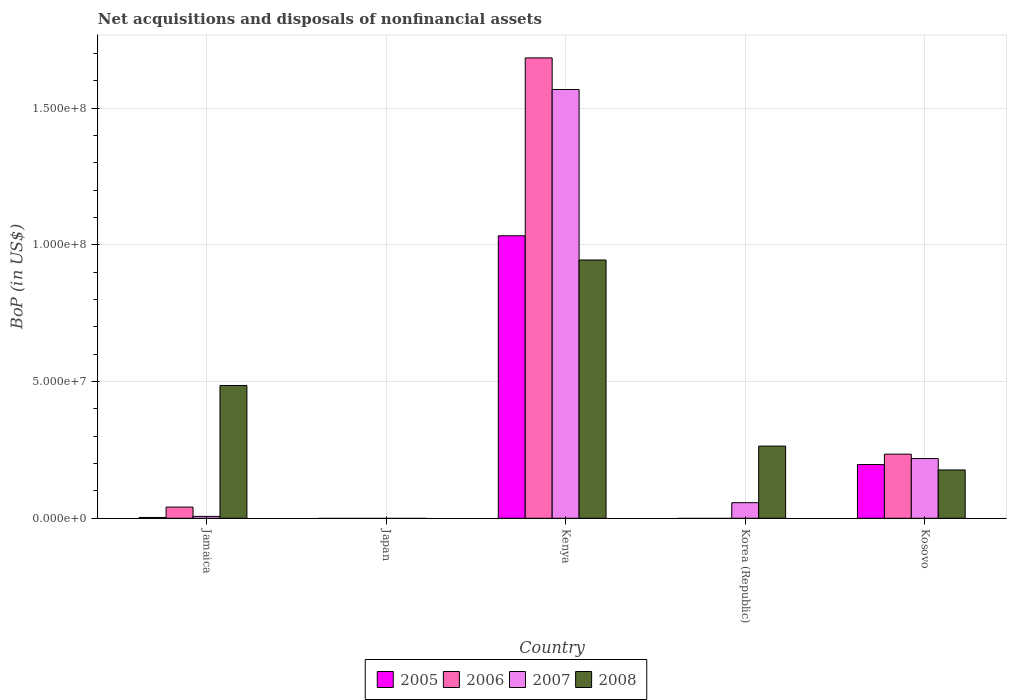How many different coloured bars are there?
Offer a very short reply. 4. Are the number of bars per tick equal to the number of legend labels?
Make the answer very short. No. Are the number of bars on each tick of the X-axis equal?
Keep it short and to the point. No. What is the label of the 4th group of bars from the left?
Give a very brief answer. Korea (Republic). In how many cases, is the number of bars for a given country not equal to the number of legend labels?
Give a very brief answer. 2. What is the Balance of Payments in 2008 in Jamaica?
Ensure brevity in your answer.  4.86e+07. Across all countries, what is the maximum Balance of Payments in 2008?
Ensure brevity in your answer.  9.45e+07. Across all countries, what is the minimum Balance of Payments in 2007?
Keep it short and to the point. 0. In which country was the Balance of Payments in 2006 maximum?
Offer a very short reply. Kenya. What is the total Balance of Payments in 2007 in the graph?
Give a very brief answer. 1.85e+08. What is the difference between the Balance of Payments in 2005 in Jamaica and that in Kosovo?
Offer a terse response. -1.93e+07. What is the difference between the Balance of Payments in 2007 in Korea (Republic) and the Balance of Payments in 2005 in Kenya?
Keep it short and to the point. -9.76e+07. What is the average Balance of Payments in 2008 per country?
Make the answer very short. 3.74e+07. What is the difference between the Balance of Payments of/in 2008 and Balance of Payments of/in 2006 in Kosovo?
Keep it short and to the point. -5.78e+06. What is the ratio of the Balance of Payments in 2006 in Jamaica to that in Kosovo?
Make the answer very short. 0.17. Is the Balance of Payments in 2008 in Jamaica less than that in Korea (Republic)?
Your answer should be very brief. No. Is the difference between the Balance of Payments in 2008 in Kenya and Kosovo greater than the difference between the Balance of Payments in 2006 in Kenya and Kosovo?
Offer a very short reply. No. What is the difference between the highest and the second highest Balance of Payments in 2007?
Make the answer very short. -1.35e+08. What is the difference between the highest and the lowest Balance of Payments in 2006?
Provide a short and direct response. 1.68e+08. In how many countries, is the Balance of Payments in 2008 greater than the average Balance of Payments in 2008 taken over all countries?
Provide a short and direct response. 2. Is it the case that in every country, the sum of the Balance of Payments in 2006 and Balance of Payments in 2005 is greater than the Balance of Payments in 2008?
Your answer should be very brief. No. Are all the bars in the graph horizontal?
Offer a terse response. No. Where does the legend appear in the graph?
Offer a very short reply. Bottom center. How are the legend labels stacked?
Your answer should be very brief. Horizontal. What is the title of the graph?
Provide a short and direct response. Net acquisitions and disposals of nonfinancial assets. What is the label or title of the Y-axis?
Offer a terse response. BoP (in US$). What is the BoP (in US$) in 2006 in Jamaica?
Provide a short and direct response. 4.09e+06. What is the BoP (in US$) of 2007 in Jamaica?
Keep it short and to the point. 6.90e+05. What is the BoP (in US$) in 2008 in Jamaica?
Ensure brevity in your answer.  4.86e+07. What is the BoP (in US$) in 2005 in Japan?
Give a very brief answer. 0. What is the BoP (in US$) in 2006 in Japan?
Make the answer very short. 0. What is the BoP (in US$) of 2007 in Japan?
Make the answer very short. 0. What is the BoP (in US$) in 2005 in Kenya?
Offer a very short reply. 1.03e+08. What is the BoP (in US$) of 2006 in Kenya?
Make the answer very short. 1.68e+08. What is the BoP (in US$) of 2007 in Kenya?
Make the answer very short. 1.57e+08. What is the BoP (in US$) of 2008 in Kenya?
Offer a terse response. 9.45e+07. What is the BoP (in US$) of 2006 in Korea (Republic)?
Provide a short and direct response. 0. What is the BoP (in US$) of 2007 in Korea (Republic)?
Your answer should be compact. 5.70e+06. What is the BoP (in US$) in 2008 in Korea (Republic)?
Keep it short and to the point. 2.64e+07. What is the BoP (in US$) of 2005 in Kosovo?
Offer a terse response. 1.96e+07. What is the BoP (in US$) in 2006 in Kosovo?
Your answer should be compact. 2.35e+07. What is the BoP (in US$) in 2007 in Kosovo?
Your answer should be very brief. 2.19e+07. What is the BoP (in US$) in 2008 in Kosovo?
Offer a terse response. 1.77e+07. Across all countries, what is the maximum BoP (in US$) in 2005?
Your response must be concise. 1.03e+08. Across all countries, what is the maximum BoP (in US$) of 2006?
Give a very brief answer. 1.68e+08. Across all countries, what is the maximum BoP (in US$) of 2007?
Ensure brevity in your answer.  1.57e+08. Across all countries, what is the maximum BoP (in US$) in 2008?
Your answer should be very brief. 9.45e+07. Across all countries, what is the minimum BoP (in US$) in 2005?
Ensure brevity in your answer.  0. Across all countries, what is the minimum BoP (in US$) of 2006?
Offer a very short reply. 0. Across all countries, what is the minimum BoP (in US$) of 2007?
Provide a succinct answer. 0. What is the total BoP (in US$) in 2005 in the graph?
Ensure brevity in your answer.  1.23e+08. What is the total BoP (in US$) of 2006 in the graph?
Your answer should be very brief. 1.96e+08. What is the total BoP (in US$) in 2007 in the graph?
Provide a short and direct response. 1.85e+08. What is the total BoP (in US$) in 2008 in the graph?
Ensure brevity in your answer.  1.87e+08. What is the difference between the BoP (in US$) in 2005 in Jamaica and that in Kenya?
Provide a succinct answer. -1.03e+08. What is the difference between the BoP (in US$) in 2006 in Jamaica and that in Kenya?
Your response must be concise. -1.64e+08. What is the difference between the BoP (in US$) in 2007 in Jamaica and that in Kenya?
Ensure brevity in your answer.  -1.56e+08. What is the difference between the BoP (in US$) in 2008 in Jamaica and that in Kenya?
Offer a terse response. -4.59e+07. What is the difference between the BoP (in US$) of 2007 in Jamaica and that in Korea (Republic)?
Your answer should be compact. -5.01e+06. What is the difference between the BoP (in US$) in 2008 in Jamaica and that in Korea (Republic)?
Offer a terse response. 2.22e+07. What is the difference between the BoP (in US$) in 2005 in Jamaica and that in Kosovo?
Your answer should be very brief. -1.93e+07. What is the difference between the BoP (in US$) in 2006 in Jamaica and that in Kosovo?
Keep it short and to the point. -1.94e+07. What is the difference between the BoP (in US$) of 2007 in Jamaica and that in Kosovo?
Give a very brief answer. -2.12e+07. What is the difference between the BoP (in US$) in 2008 in Jamaica and that in Kosovo?
Offer a terse response. 3.09e+07. What is the difference between the BoP (in US$) of 2007 in Kenya and that in Korea (Republic)?
Provide a succinct answer. 1.51e+08. What is the difference between the BoP (in US$) of 2008 in Kenya and that in Korea (Republic)?
Offer a terse response. 6.81e+07. What is the difference between the BoP (in US$) in 2005 in Kenya and that in Kosovo?
Make the answer very short. 8.37e+07. What is the difference between the BoP (in US$) in 2006 in Kenya and that in Kosovo?
Ensure brevity in your answer.  1.45e+08. What is the difference between the BoP (in US$) of 2007 in Kenya and that in Kosovo?
Your answer should be very brief. 1.35e+08. What is the difference between the BoP (in US$) in 2008 in Kenya and that in Kosovo?
Ensure brevity in your answer.  7.68e+07. What is the difference between the BoP (in US$) in 2007 in Korea (Republic) and that in Kosovo?
Provide a succinct answer. -1.62e+07. What is the difference between the BoP (in US$) of 2008 in Korea (Republic) and that in Kosovo?
Keep it short and to the point. 8.73e+06. What is the difference between the BoP (in US$) in 2005 in Jamaica and the BoP (in US$) in 2006 in Kenya?
Provide a succinct answer. -1.68e+08. What is the difference between the BoP (in US$) in 2005 in Jamaica and the BoP (in US$) in 2007 in Kenya?
Keep it short and to the point. -1.57e+08. What is the difference between the BoP (in US$) of 2005 in Jamaica and the BoP (in US$) of 2008 in Kenya?
Your response must be concise. -9.42e+07. What is the difference between the BoP (in US$) of 2006 in Jamaica and the BoP (in US$) of 2007 in Kenya?
Your response must be concise. -1.53e+08. What is the difference between the BoP (in US$) in 2006 in Jamaica and the BoP (in US$) in 2008 in Kenya?
Give a very brief answer. -9.04e+07. What is the difference between the BoP (in US$) in 2007 in Jamaica and the BoP (in US$) in 2008 in Kenya?
Offer a terse response. -9.38e+07. What is the difference between the BoP (in US$) in 2005 in Jamaica and the BoP (in US$) in 2007 in Korea (Republic)?
Offer a terse response. -5.40e+06. What is the difference between the BoP (in US$) in 2005 in Jamaica and the BoP (in US$) in 2008 in Korea (Republic)?
Offer a terse response. -2.61e+07. What is the difference between the BoP (in US$) in 2006 in Jamaica and the BoP (in US$) in 2007 in Korea (Republic)?
Ensure brevity in your answer.  -1.61e+06. What is the difference between the BoP (in US$) in 2006 in Jamaica and the BoP (in US$) in 2008 in Korea (Republic)?
Offer a terse response. -2.23e+07. What is the difference between the BoP (in US$) in 2007 in Jamaica and the BoP (in US$) in 2008 in Korea (Republic)?
Keep it short and to the point. -2.57e+07. What is the difference between the BoP (in US$) of 2005 in Jamaica and the BoP (in US$) of 2006 in Kosovo?
Provide a short and direct response. -2.32e+07. What is the difference between the BoP (in US$) in 2005 in Jamaica and the BoP (in US$) in 2007 in Kosovo?
Your response must be concise. -2.16e+07. What is the difference between the BoP (in US$) of 2005 in Jamaica and the BoP (in US$) of 2008 in Kosovo?
Your answer should be compact. -1.74e+07. What is the difference between the BoP (in US$) of 2006 in Jamaica and the BoP (in US$) of 2007 in Kosovo?
Offer a very short reply. -1.78e+07. What is the difference between the BoP (in US$) of 2006 in Jamaica and the BoP (in US$) of 2008 in Kosovo?
Provide a succinct answer. -1.36e+07. What is the difference between the BoP (in US$) of 2007 in Jamaica and the BoP (in US$) of 2008 in Kosovo?
Give a very brief answer. -1.70e+07. What is the difference between the BoP (in US$) of 2005 in Kenya and the BoP (in US$) of 2007 in Korea (Republic)?
Give a very brief answer. 9.76e+07. What is the difference between the BoP (in US$) in 2005 in Kenya and the BoP (in US$) in 2008 in Korea (Republic)?
Your answer should be very brief. 7.69e+07. What is the difference between the BoP (in US$) in 2006 in Kenya and the BoP (in US$) in 2007 in Korea (Republic)?
Provide a short and direct response. 1.63e+08. What is the difference between the BoP (in US$) of 2006 in Kenya and the BoP (in US$) of 2008 in Korea (Republic)?
Ensure brevity in your answer.  1.42e+08. What is the difference between the BoP (in US$) in 2007 in Kenya and the BoP (in US$) in 2008 in Korea (Republic)?
Your response must be concise. 1.30e+08. What is the difference between the BoP (in US$) of 2005 in Kenya and the BoP (in US$) of 2006 in Kosovo?
Offer a very short reply. 7.99e+07. What is the difference between the BoP (in US$) in 2005 in Kenya and the BoP (in US$) in 2007 in Kosovo?
Provide a succinct answer. 8.15e+07. What is the difference between the BoP (in US$) in 2005 in Kenya and the BoP (in US$) in 2008 in Kosovo?
Your answer should be compact. 8.57e+07. What is the difference between the BoP (in US$) in 2006 in Kenya and the BoP (in US$) in 2007 in Kosovo?
Offer a terse response. 1.47e+08. What is the difference between the BoP (in US$) in 2006 in Kenya and the BoP (in US$) in 2008 in Kosovo?
Provide a short and direct response. 1.51e+08. What is the difference between the BoP (in US$) of 2007 in Kenya and the BoP (in US$) of 2008 in Kosovo?
Offer a terse response. 1.39e+08. What is the difference between the BoP (in US$) of 2007 in Korea (Republic) and the BoP (in US$) of 2008 in Kosovo?
Provide a short and direct response. -1.20e+07. What is the average BoP (in US$) of 2005 per country?
Give a very brief answer. 2.47e+07. What is the average BoP (in US$) of 2006 per country?
Ensure brevity in your answer.  3.92e+07. What is the average BoP (in US$) in 2007 per country?
Ensure brevity in your answer.  3.70e+07. What is the average BoP (in US$) in 2008 per country?
Give a very brief answer. 3.74e+07. What is the difference between the BoP (in US$) of 2005 and BoP (in US$) of 2006 in Jamaica?
Give a very brief answer. -3.79e+06. What is the difference between the BoP (in US$) in 2005 and BoP (in US$) in 2007 in Jamaica?
Your answer should be very brief. -3.90e+05. What is the difference between the BoP (in US$) in 2005 and BoP (in US$) in 2008 in Jamaica?
Keep it short and to the point. -4.83e+07. What is the difference between the BoP (in US$) in 2006 and BoP (in US$) in 2007 in Jamaica?
Provide a short and direct response. 3.40e+06. What is the difference between the BoP (in US$) in 2006 and BoP (in US$) in 2008 in Jamaica?
Keep it short and to the point. -4.45e+07. What is the difference between the BoP (in US$) in 2007 and BoP (in US$) in 2008 in Jamaica?
Make the answer very short. -4.79e+07. What is the difference between the BoP (in US$) in 2005 and BoP (in US$) in 2006 in Kenya?
Offer a very short reply. -6.51e+07. What is the difference between the BoP (in US$) in 2005 and BoP (in US$) in 2007 in Kenya?
Your answer should be compact. -5.35e+07. What is the difference between the BoP (in US$) of 2005 and BoP (in US$) of 2008 in Kenya?
Give a very brief answer. 8.86e+06. What is the difference between the BoP (in US$) of 2006 and BoP (in US$) of 2007 in Kenya?
Provide a succinct answer. 1.16e+07. What is the difference between the BoP (in US$) of 2006 and BoP (in US$) of 2008 in Kenya?
Offer a terse response. 7.39e+07. What is the difference between the BoP (in US$) in 2007 and BoP (in US$) in 2008 in Kenya?
Keep it short and to the point. 6.24e+07. What is the difference between the BoP (in US$) in 2007 and BoP (in US$) in 2008 in Korea (Republic)?
Make the answer very short. -2.07e+07. What is the difference between the BoP (in US$) of 2005 and BoP (in US$) of 2006 in Kosovo?
Your answer should be very brief. -3.81e+06. What is the difference between the BoP (in US$) in 2005 and BoP (in US$) in 2007 in Kosovo?
Keep it short and to the point. -2.21e+06. What is the difference between the BoP (in US$) of 2005 and BoP (in US$) of 2008 in Kosovo?
Offer a very short reply. 1.97e+06. What is the difference between the BoP (in US$) in 2006 and BoP (in US$) in 2007 in Kosovo?
Your response must be concise. 1.60e+06. What is the difference between the BoP (in US$) in 2006 and BoP (in US$) in 2008 in Kosovo?
Your response must be concise. 5.78e+06. What is the difference between the BoP (in US$) in 2007 and BoP (in US$) in 2008 in Kosovo?
Ensure brevity in your answer.  4.18e+06. What is the ratio of the BoP (in US$) in 2005 in Jamaica to that in Kenya?
Make the answer very short. 0. What is the ratio of the BoP (in US$) in 2006 in Jamaica to that in Kenya?
Ensure brevity in your answer.  0.02. What is the ratio of the BoP (in US$) of 2007 in Jamaica to that in Kenya?
Your response must be concise. 0. What is the ratio of the BoP (in US$) of 2008 in Jamaica to that in Kenya?
Your response must be concise. 0.51. What is the ratio of the BoP (in US$) of 2007 in Jamaica to that in Korea (Republic)?
Provide a succinct answer. 0.12. What is the ratio of the BoP (in US$) in 2008 in Jamaica to that in Korea (Republic)?
Provide a succinct answer. 1.84. What is the ratio of the BoP (in US$) in 2005 in Jamaica to that in Kosovo?
Your answer should be very brief. 0.02. What is the ratio of the BoP (in US$) of 2006 in Jamaica to that in Kosovo?
Keep it short and to the point. 0.17. What is the ratio of the BoP (in US$) of 2007 in Jamaica to that in Kosovo?
Ensure brevity in your answer.  0.03. What is the ratio of the BoP (in US$) in 2008 in Jamaica to that in Kosovo?
Offer a terse response. 2.75. What is the ratio of the BoP (in US$) of 2007 in Kenya to that in Korea (Republic)?
Make the answer very short. 27.52. What is the ratio of the BoP (in US$) in 2008 in Kenya to that in Korea (Republic)?
Give a very brief answer. 3.58. What is the ratio of the BoP (in US$) of 2005 in Kenya to that in Kosovo?
Make the answer very short. 5.26. What is the ratio of the BoP (in US$) in 2006 in Kenya to that in Kosovo?
Your response must be concise. 7.18. What is the ratio of the BoP (in US$) in 2007 in Kenya to that in Kosovo?
Provide a succinct answer. 7.18. What is the ratio of the BoP (in US$) in 2008 in Kenya to that in Kosovo?
Make the answer very short. 5.35. What is the ratio of the BoP (in US$) in 2007 in Korea (Republic) to that in Kosovo?
Provide a short and direct response. 0.26. What is the ratio of the BoP (in US$) of 2008 in Korea (Republic) to that in Kosovo?
Ensure brevity in your answer.  1.49. What is the difference between the highest and the second highest BoP (in US$) in 2005?
Give a very brief answer. 8.37e+07. What is the difference between the highest and the second highest BoP (in US$) in 2006?
Offer a very short reply. 1.45e+08. What is the difference between the highest and the second highest BoP (in US$) of 2007?
Your answer should be very brief. 1.35e+08. What is the difference between the highest and the second highest BoP (in US$) of 2008?
Give a very brief answer. 4.59e+07. What is the difference between the highest and the lowest BoP (in US$) in 2005?
Provide a succinct answer. 1.03e+08. What is the difference between the highest and the lowest BoP (in US$) of 2006?
Offer a very short reply. 1.68e+08. What is the difference between the highest and the lowest BoP (in US$) in 2007?
Offer a terse response. 1.57e+08. What is the difference between the highest and the lowest BoP (in US$) in 2008?
Give a very brief answer. 9.45e+07. 